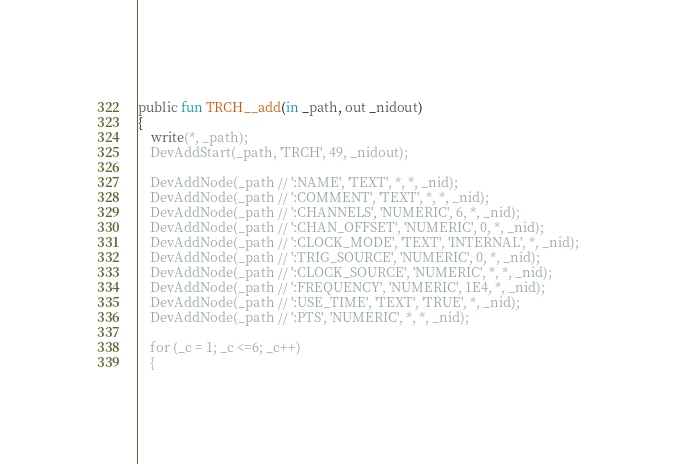<code> <loc_0><loc_0><loc_500><loc_500><_SML_>public fun TRCH__add(in _path, out _nidout)
{
    write(*, _path);
    DevAddStart(_path, 'TRCH', 49, _nidout);

    DevAddNode(_path // ':NAME', 'TEXT', *, *, _nid);
    DevAddNode(_path // ':COMMENT', 'TEXT', *, *, _nid);
    DevAddNode(_path // ':CHANNELS', 'NUMERIC', 6, *, _nid);
    DevAddNode(_path // ':CHAN_OFFSET', 'NUMERIC', 0, *, _nid);
    DevAddNode(_path // ':CLOCK_MODE', 'TEXT', 'INTERNAL', *, _nid);
    DevAddNode(_path // ':TRIG_SOURCE', 'NUMERIC', 0, *, _nid);
    DevAddNode(_path // ':CLOCK_SOURCE', 'NUMERIC', *, *, _nid);
    DevAddNode(_path // ':FREQUENCY', 'NUMERIC', 1E4, *, _nid);
    DevAddNode(_path // ':USE_TIME', 'TEXT', 'TRUE', *, _nid);
    DevAddNode(_path // ':PTS', 'NUMERIC', *, *, _nid);

    for (_c = 1; _c <=6; _c++)
    {</code> 